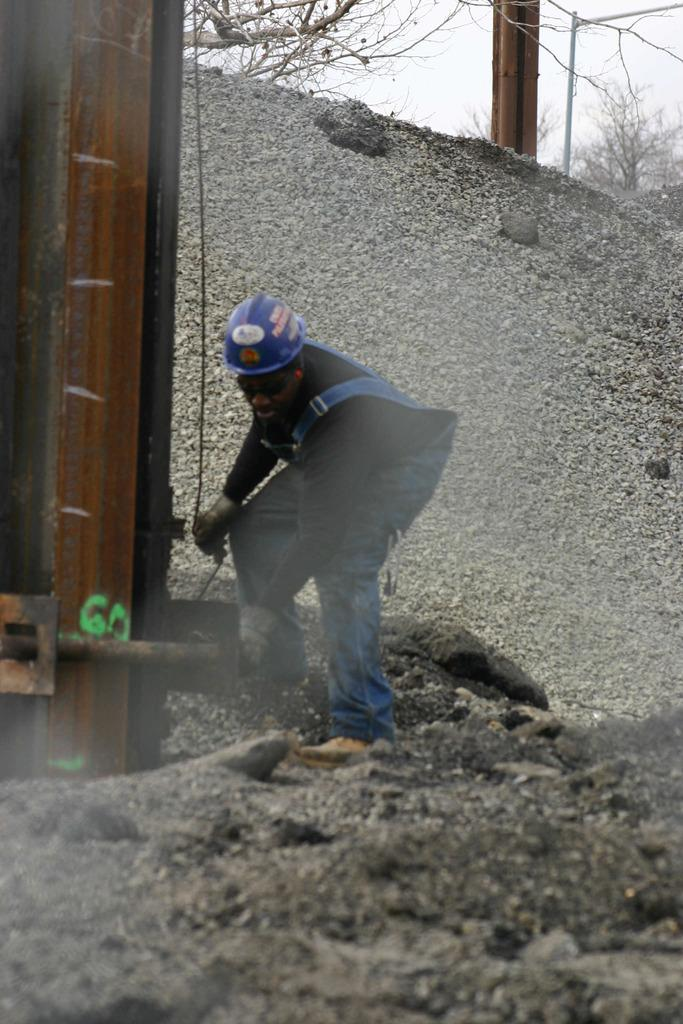What is the main subject of the image? There is a person in the image. What is the person holding in the image? The person is holding a wire. What can be seen in the background of the image? There are trees in the background of the image. What type of jail can be seen in the image? There is no jail present in the image; it features a person holding a wire with trees in the background. Is the person in the image a writer? There is no information about the person's occupation or identity in the image, so it cannot be determined if they are a writer. 